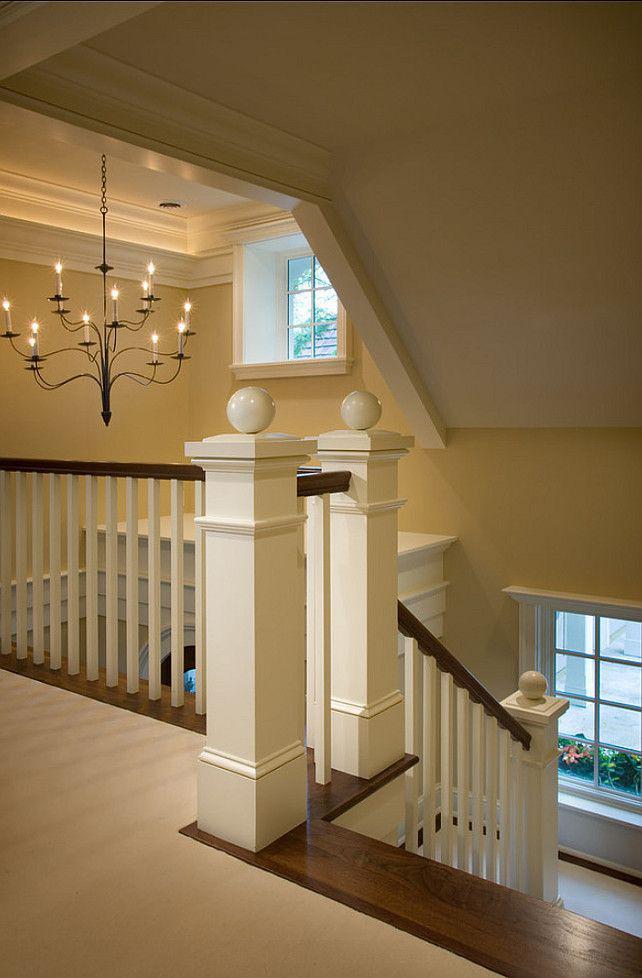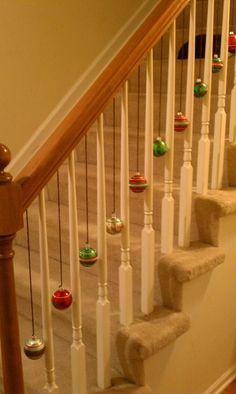The first image is the image on the left, the second image is the image on the right. Analyze the images presented: Is the assertion "The plant in the image on the left is sitting beside the stairway." valid? Answer yes or no. No. 